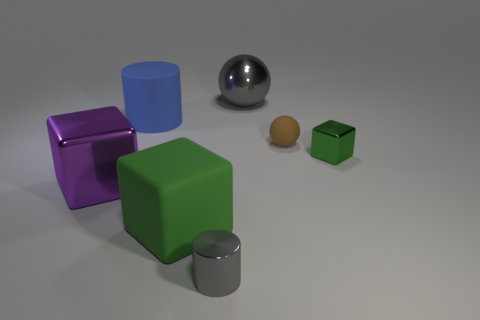How many metallic things are either green things or tiny gray cylinders?
Make the answer very short. 2. What shape is the green object that is made of the same material as the big gray ball?
Provide a short and direct response. Cube. What number of green rubber things are the same shape as the big gray object?
Provide a short and direct response. 0. Is the shape of the blue matte object in front of the large gray metallic object the same as the shiny thing that is in front of the big green thing?
Your answer should be very brief. Yes. How many things are small brown matte balls or things right of the large purple thing?
Ensure brevity in your answer.  6. What shape is the thing that is the same color as the small cylinder?
Your answer should be very brief. Sphere. What number of green things have the same size as the rubber sphere?
Your answer should be very brief. 1. What number of gray objects are matte blocks or big metal objects?
Your response must be concise. 1. What is the shape of the matte object that is right of the small metal thing to the left of the tiny green metallic object?
Your answer should be very brief. Sphere. What shape is the green metallic object that is the same size as the brown ball?
Provide a succinct answer. Cube. 